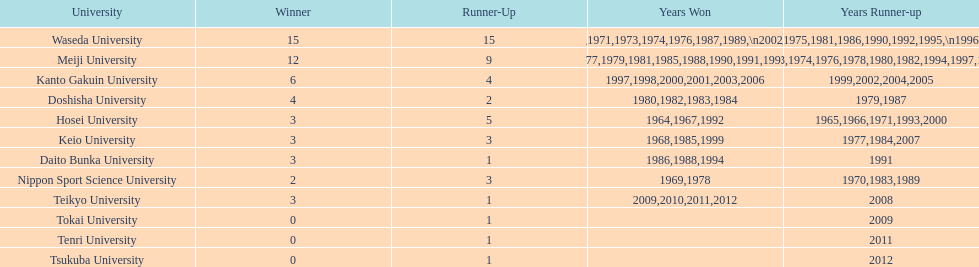Hosei triumphed in 196 Waseda University. I'm looking to parse the entire table for insights. Could you assist me with that? {'header': ['University', 'Winner', 'Runner-Up', 'Years Won', 'Years Runner-up'], 'rows': [['Waseda University', '15', '15', '1965,1966,1968,1970,1971,1973,1974,1976,1987,1989,\\n2002,2004,2005,2007,2008', '1964,1967,1969,1972,1975,1981,1986,1990,1992,1995,\\n1996,2001,2003,2006,2010'], ['Meiji University', '12', '9', '1972,1975,1977,1979,1981,1985,1988,1990,1991,1993,\\n1995,1996', '1973,1974,1976,1978,1980,1982,1994,1997,1998'], ['Kanto Gakuin University', '6', '4', '1997,1998,2000,2001,2003,2006', '1999,2002,2004,2005'], ['Doshisha University', '4', '2', '1980,1982,1983,1984', '1979,1987'], ['Hosei University', '3', '5', '1964,1967,1992', '1965,1966,1971,1993,2000'], ['Keio University', '3', '3', '1968,1985,1999', '1977,1984,2007'], ['Daito Bunka University', '3', '1', '1986,1988,1994', '1991'], ['Nippon Sport Science University', '2', '3', '1969,1978', '1970,1983,1989'], ['Teikyo University', '3', '1', '2009,2010,2011,2012', '2008'], ['Tokai University', '0', '1', '', '2009'], ['Tenri University', '0', '1', '', '2011'], ['Tsukuba University', '0', '1', '', '2012']]} 